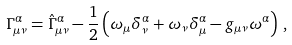<formula> <loc_0><loc_0><loc_500><loc_500>\Gamma ^ { \alpha } _ { \mu \nu } = \hat { \Gamma } ^ { \alpha } _ { \mu \nu } - \frac { 1 } { 2 } \left ( \omega _ { \mu } \delta _ { \nu } ^ { \alpha } + \omega _ { \nu } \delta _ { \mu } ^ { \alpha } - g _ { \mu \nu } \omega ^ { \alpha } \right ) \, ,</formula> 